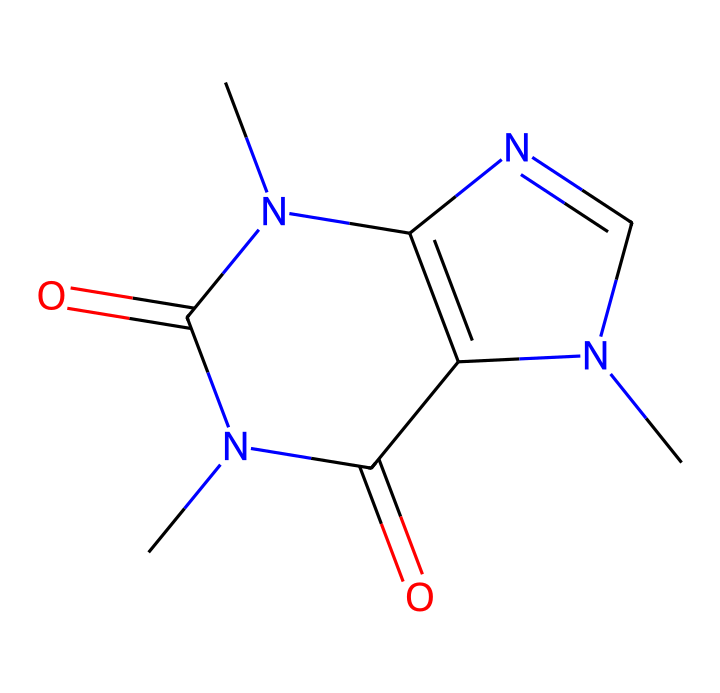What is the total number of nitrogen atoms in the structure? The SMILES representation has three 'N' characters, indicating there are three nitrogen atoms present in the structure.
Answer: three How many rings are present in this compound? By analyzing the structure, there are two distinct ring systems identified: one containing the nitrogen atoms and the other involving carbon and nitrogen atoms bound together. Therefore, the total is two rings.
Answer: two What type of compound is caffeine categorized as? Caffeine is classified as an alkaloid, which is a class of nitrogen-containing compounds commonly found in plants, known for their physiological effects.
Answer: alkaloid Which atoms provide the basic framework for caffeine's structure? The primary framework of caffeine consists mostly of carbon and nitrogen atoms, with carbon providing the backbone and nitrogen contributing to the functionality of the compound as a stimulant.
Answer: carbon and nitrogen What functional groups are present in caffeine? The structure features two carbonyl groups (C=O), which represent the amide functional group, indicating the presence of functional groups common in caffeine.
Answer: carbonyl (amide) Does this compound contain any aromatic components? The structure shows that certain carbon atoms are involved in double bonds and are part of cyclic structures; thus, it contains aromatic rings typical in many alkaloids including caffeine.
Answer: yes How many total carbon atoms are in caffeine? By counting the 'C' characters in the SMILES representation, there are eight carbon atoms present, which is indicative of the basic structure of caffeine.
Answer: eight 